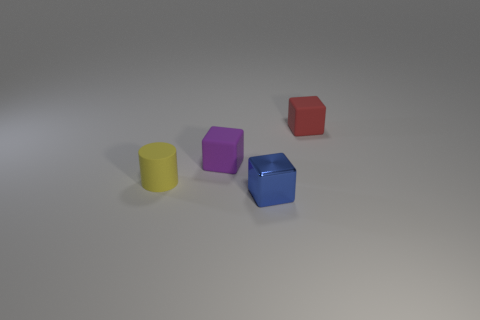Add 1 big red metal objects. How many objects exist? 5 Subtract all cylinders. How many objects are left? 3 Add 4 brown matte blocks. How many brown matte blocks exist? 4 Subtract 0 cyan balls. How many objects are left? 4 Subtract all matte cylinders. Subtract all purple objects. How many objects are left? 2 Add 1 blue metallic cubes. How many blue metallic cubes are left? 2 